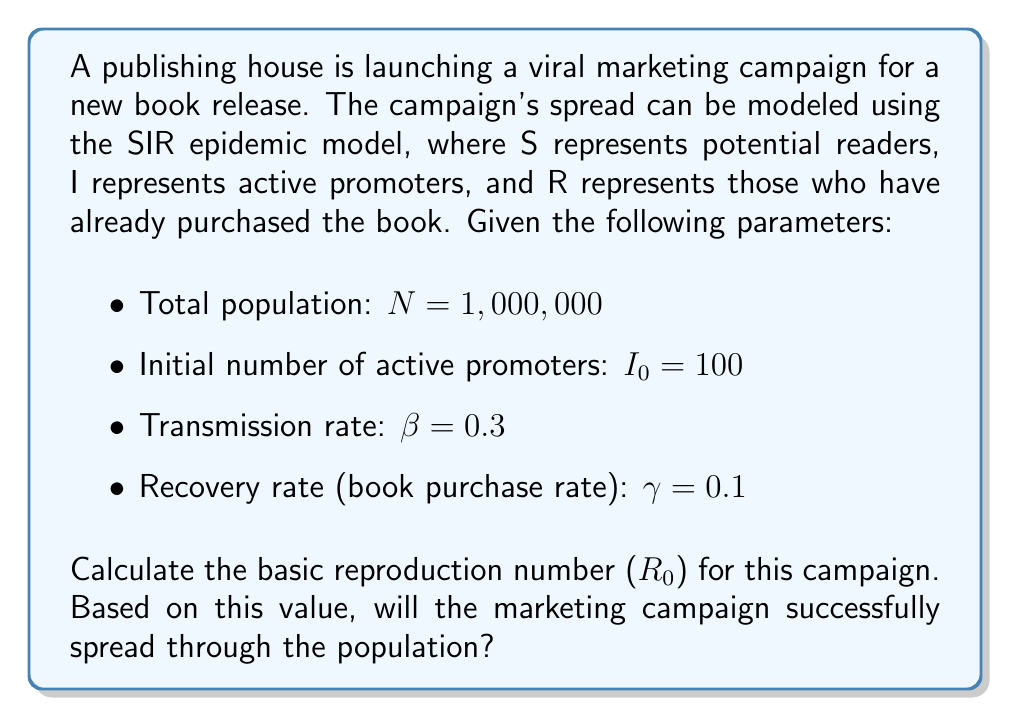Show me your answer to this math problem. To solve this problem, we'll follow these steps:

1. Understand the SIR model parameters:
   - $\beta$ is the transmission rate (rate at which potential readers become active promoters)
   - $\gamma$ is the recovery rate (rate at which active promoters purchase the book)

2. Calculate the basic reproduction number ($R_0$):
   The basic reproduction number is defined as:

   $$R_0 = \frac{\beta}{\gamma}$$

   Substituting the given values:

   $$R_0 = \frac{0.3}{0.1} = 3$$

3. Interpret the result:
   - If $R_0 > 1$, the marketing campaign will spread successfully.
   - If $R_0 < 1$, the marketing campaign will die out.

   In this case, $R_0 = 3 > 1$, so the marketing campaign will successfully spread through the population.

4. Additional context:
   The $R_0$ value of 3 means that, on average, each active promoter will generate 3 new active promoters before purchasing the book. This indicates a strong potential for exponential growth in the campaign's reach.
Answer: $R_0 = 3$; The campaign will successfully spread. 